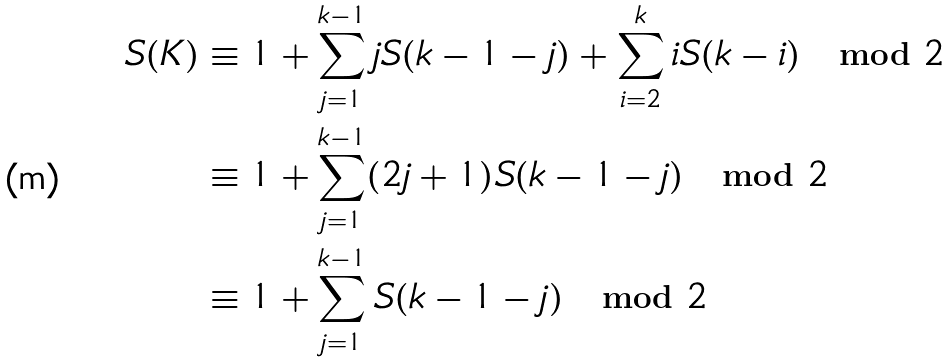Convert formula to latex. <formula><loc_0><loc_0><loc_500><loc_500>S ( K ) & \equiv 1 + \sum _ { j = 1 } ^ { k - 1 } j S ( k - 1 - j ) + \sum _ { i = 2 } ^ { k } i S ( k - i ) \mod 2 \\ & \equiv 1 + \sum _ { j = 1 } ^ { k - 1 } ( 2 j + 1 ) S ( k - 1 - j ) \mod 2 \\ & \equiv 1 + \sum _ { j = 1 } ^ { k - 1 } S ( k - 1 - j ) \mod 2</formula> 